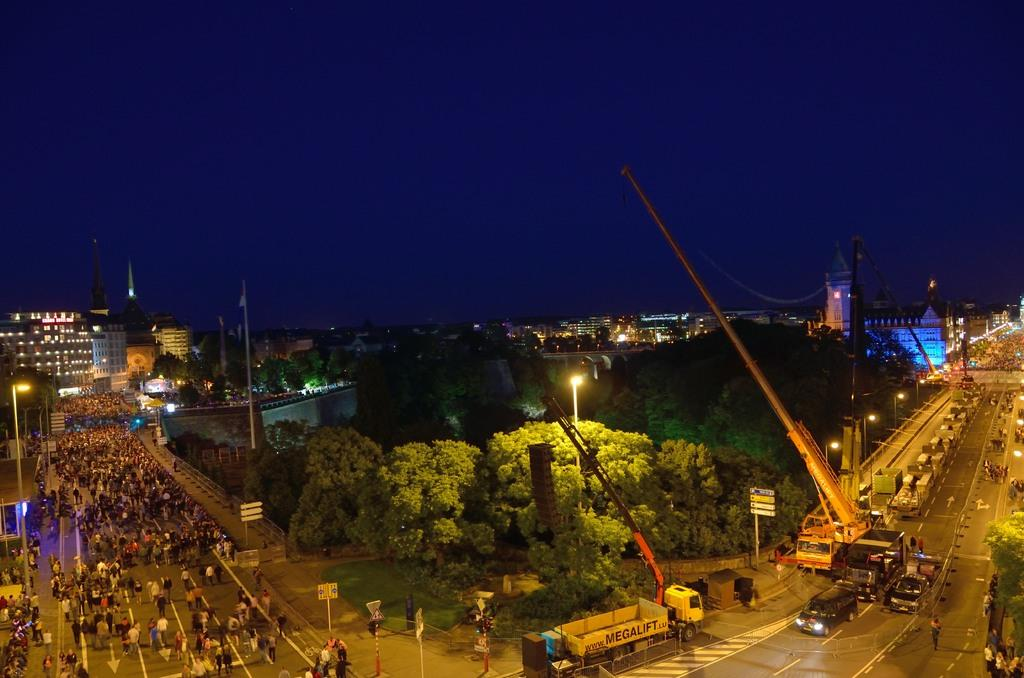What can be seen on the roads in the image? There are people and vehicles on the roads in the image. What is visible beside the road in the image? Trees and buildings are visible beside the road in the image. What type of informational or directional signs are present in the image? Sign boards are present in the image. What historical event is being commemorated in the image? There is no indication of a historical event being commemorated in the image. Can you describe the room where the people and vehicles are located in the image? The image does not show a room; it shows an outdoor scene with roads, trees, buildings, and sign boards. 